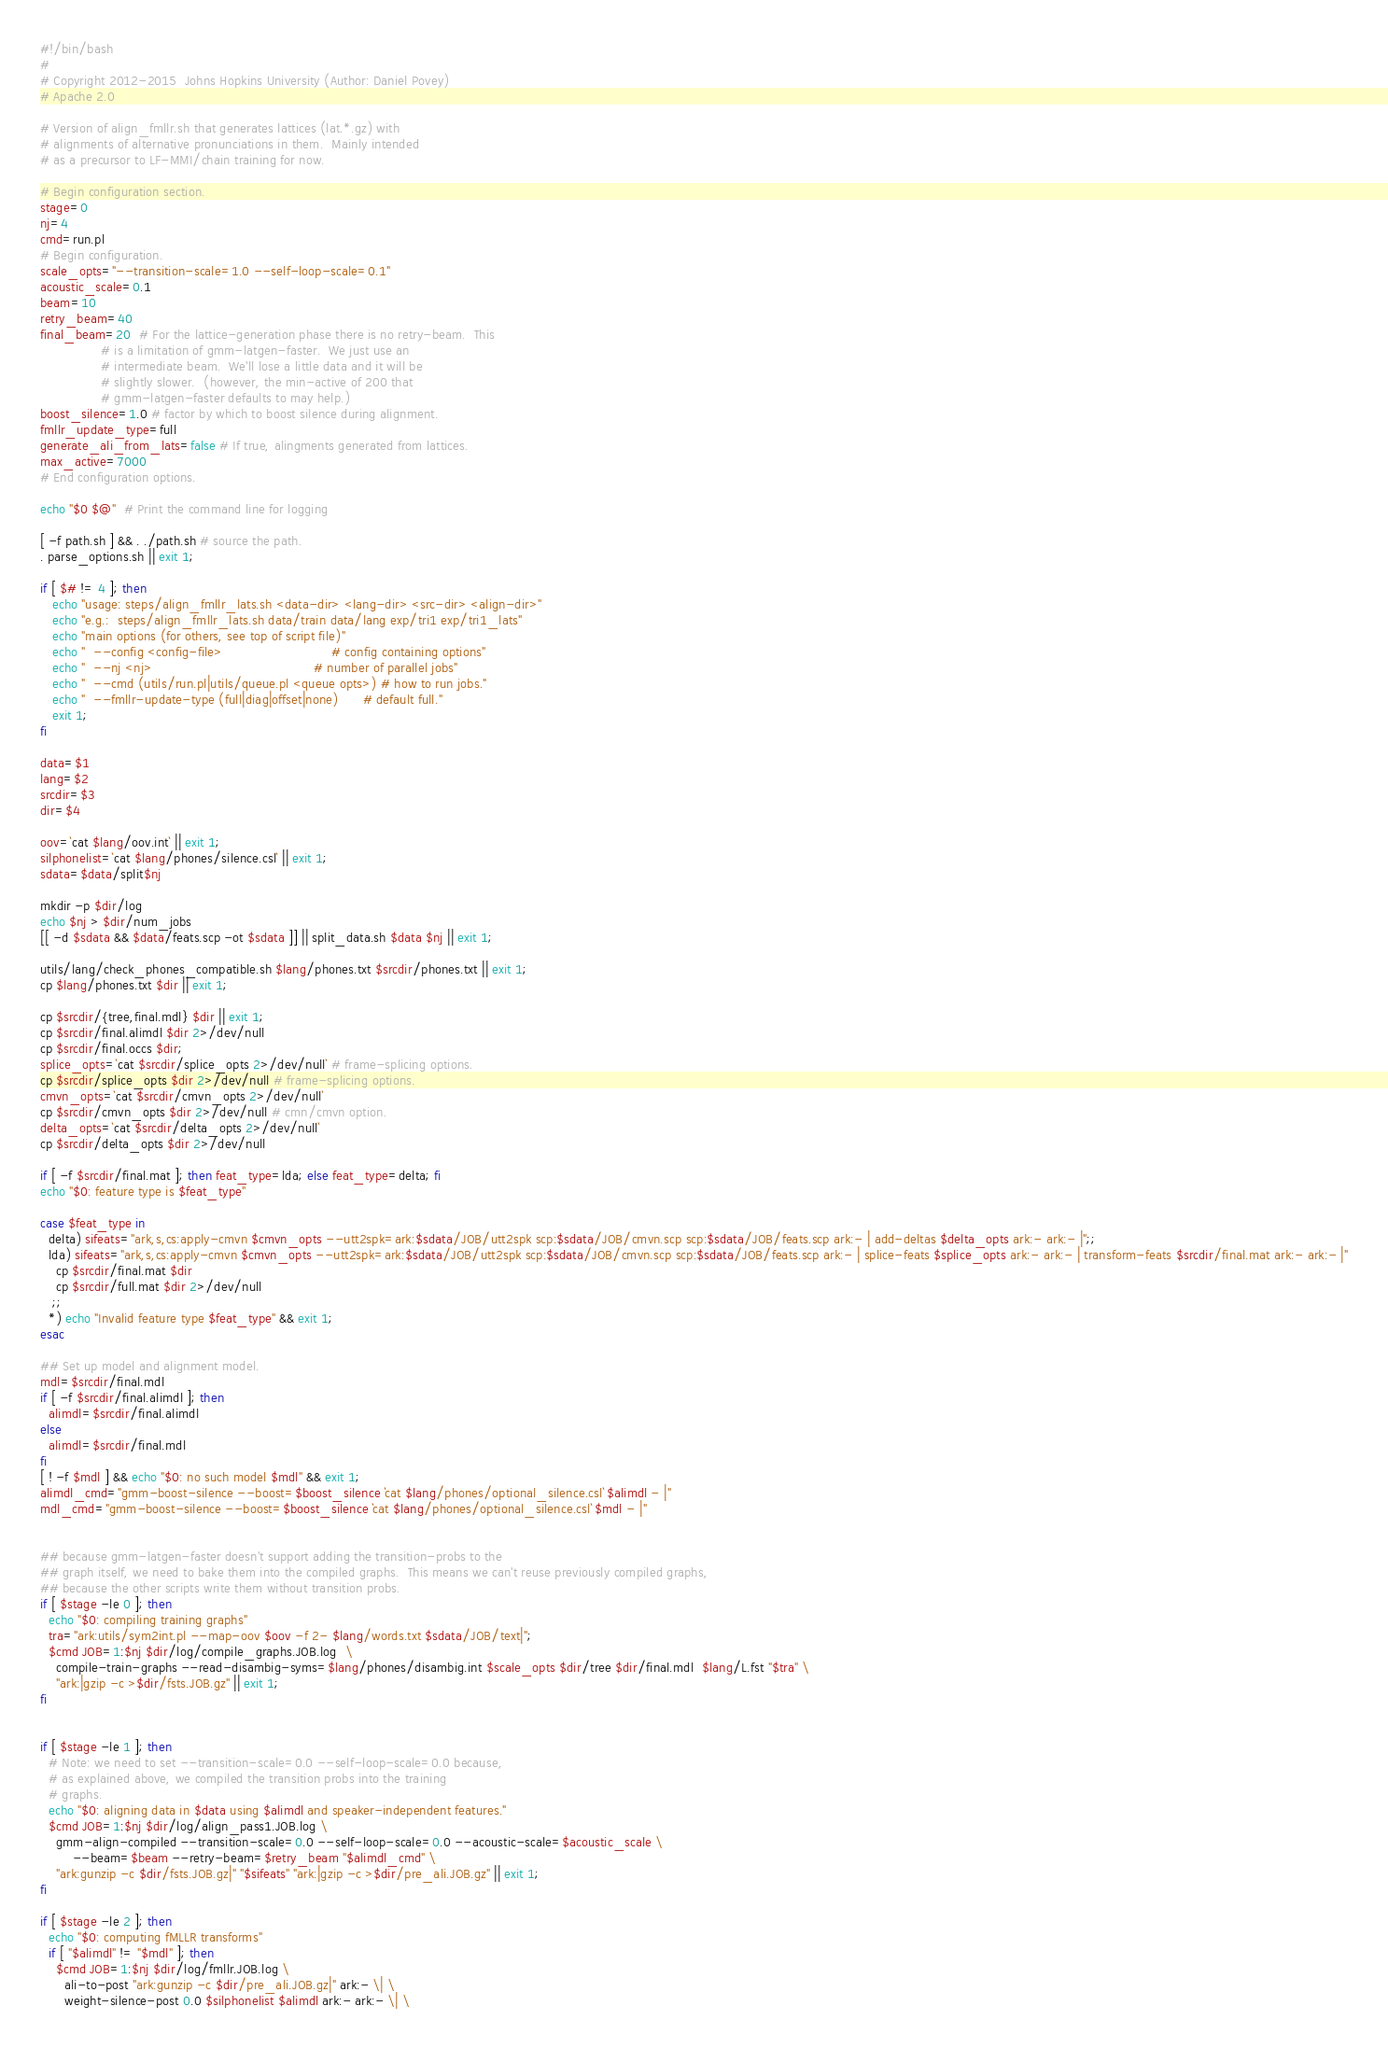Convert code to text. <code><loc_0><loc_0><loc_500><loc_500><_Bash_>#!/bin/bash
#
# Copyright 2012-2015  Johns Hopkins University (Author: Daniel Povey)
# Apache 2.0

# Version of align_fmllr.sh that generates lattices (lat.*.gz) with
# alignments of alternative pronunciations in them.  Mainly intended
# as a precursor to LF-MMI/chain training for now.

# Begin configuration section.
stage=0
nj=4
cmd=run.pl
# Begin configuration.
scale_opts="--transition-scale=1.0 --self-loop-scale=0.1"
acoustic_scale=0.1
beam=10
retry_beam=40
final_beam=20  # For the lattice-generation phase there is no retry-beam.  This
               # is a limitation of gmm-latgen-faster.  We just use an
               # intermediate beam.  We'll lose a little data and it will be
               # slightly slower.  (however, the min-active of 200 that
               # gmm-latgen-faster defaults to may help.)
boost_silence=1.0 # factor by which to boost silence during alignment.
fmllr_update_type=full
generate_ali_from_lats=false # If true, alingments generated from lattices.
max_active=7000
# End configuration options.

echo "$0 $@"  # Print the command line for logging

[ -f path.sh ] && . ./path.sh # source the path.
. parse_options.sh || exit 1;

if [ $# != 4 ]; then
   echo "usage: steps/align_fmllr_lats.sh <data-dir> <lang-dir> <src-dir> <align-dir>"
   echo "e.g.:  steps/align_fmllr_lats.sh data/train data/lang exp/tri1 exp/tri1_lats"
   echo "main options (for others, see top of script file)"
   echo "  --config <config-file>                           # config containing options"
   echo "  --nj <nj>                                        # number of parallel jobs"
   echo "  --cmd (utils/run.pl|utils/queue.pl <queue opts>) # how to run jobs."
   echo "  --fmllr-update-type (full|diag|offset|none)      # default full."
   exit 1;
fi

data=$1
lang=$2
srcdir=$3
dir=$4

oov=`cat $lang/oov.int` || exit 1;
silphonelist=`cat $lang/phones/silence.csl` || exit 1;
sdata=$data/split$nj

mkdir -p $dir/log
echo $nj > $dir/num_jobs
[[ -d $sdata && $data/feats.scp -ot $sdata ]] || split_data.sh $data $nj || exit 1;

utils/lang/check_phones_compatible.sh $lang/phones.txt $srcdir/phones.txt || exit 1;
cp $lang/phones.txt $dir || exit 1;

cp $srcdir/{tree,final.mdl} $dir || exit 1;
cp $srcdir/final.alimdl $dir 2>/dev/null
cp $srcdir/final.occs $dir;
splice_opts=`cat $srcdir/splice_opts 2>/dev/null` # frame-splicing options.
cp $srcdir/splice_opts $dir 2>/dev/null # frame-splicing options.
cmvn_opts=`cat $srcdir/cmvn_opts 2>/dev/null`
cp $srcdir/cmvn_opts $dir 2>/dev/null # cmn/cmvn option.
delta_opts=`cat $srcdir/delta_opts 2>/dev/null`
cp $srcdir/delta_opts $dir 2>/dev/null

if [ -f $srcdir/final.mat ]; then feat_type=lda; else feat_type=delta; fi
echo "$0: feature type is $feat_type"

case $feat_type in
  delta) sifeats="ark,s,cs:apply-cmvn $cmvn_opts --utt2spk=ark:$sdata/JOB/utt2spk scp:$sdata/JOB/cmvn.scp scp:$sdata/JOB/feats.scp ark:- | add-deltas $delta_opts ark:- ark:- |";;
  lda) sifeats="ark,s,cs:apply-cmvn $cmvn_opts --utt2spk=ark:$sdata/JOB/utt2spk scp:$sdata/JOB/cmvn.scp scp:$sdata/JOB/feats.scp ark:- | splice-feats $splice_opts ark:- ark:- | transform-feats $srcdir/final.mat ark:- ark:- |"
    cp $srcdir/final.mat $dir
    cp $srcdir/full.mat $dir 2>/dev/null
   ;;
  *) echo "Invalid feature type $feat_type" && exit 1;
esac

## Set up model and alignment model.
mdl=$srcdir/final.mdl
if [ -f $srcdir/final.alimdl ]; then
  alimdl=$srcdir/final.alimdl
else
  alimdl=$srcdir/final.mdl
fi
[ ! -f $mdl ] && echo "$0: no such model $mdl" && exit 1;
alimdl_cmd="gmm-boost-silence --boost=$boost_silence `cat $lang/phones/optional_silence.csl` $alimdl - |"
mdl_cmd="gmm-boost-silence --boost=$boost_silence `cat $lang/phones/optional_silence.csl` $mdl - |"


## because gmm-latgen-faster doesn't support adding the transition-probs to the
## graph itself, we need to bake them into the compiled graphs.  This means we can't reuse previously compiled graphs,
## because the other scripts write them without transition probs.
if [ $stage -le 0 ]; then
  echo "$0: compiling training graphs"
  tra="ark:utils/sym2int.pl --map-oov $oov -f 2- $lang/words.txt $sdata/JOB/text|";
  $cmd JOB=1:$nj $dir/log/compile_graphs.JOB.log  \
    compile-train-graphs --read-disambig-syms=$lang/phones/disambig.int $scale_opts $dir/tree $dir/final.mdl  $lang/L.fst "$tra" \
    "ark:|gzip -c >$dir/fsts.JOB.gz" || exit 1;
fi


if [ $stage -le 1 ]; then
  # Note: we need to set --transition-scale=0.0 --self-loop-scale=0.0 because,
  # as explained above, we compiled the transition probs into the training
  # graphs.
  echo "$0: aligning data in $data using $alimdl and speaker-independent features."
  $cmd JOB=1:$nj $dir/log/align_pass1.JOB.log \
    gmm-align-compiled --transition-scale=0.0 --self-loop-scale=0.0 --acoustic-scale=$acoustic_scale \
        --beam=$beam --retry-beam=$retry_beam "$alimdl_cmd" \
    "ark:gunzip -c $dir/fsts.JOB.gz|" "$sifeats" "ark:|gzip -c >$dir/pre_ali.JOB.gz" || exit 1;
fi

if [ $stage -le 2 ]; then
  echo "$0: computing fMLLR transforms"
  if [ "$alimdl" != "$mdl" ]; then
    $cmd JOB=1:$nj $dir/log/fmllr.JOB.log \
      ali-to-post "ark:gunzip -c $dir/pre_ali.JOB.gz|" ark:- \| \
      weight-silence-post 0.0 $silphonelist $alimdl ark:- ark:- \| \</code> 